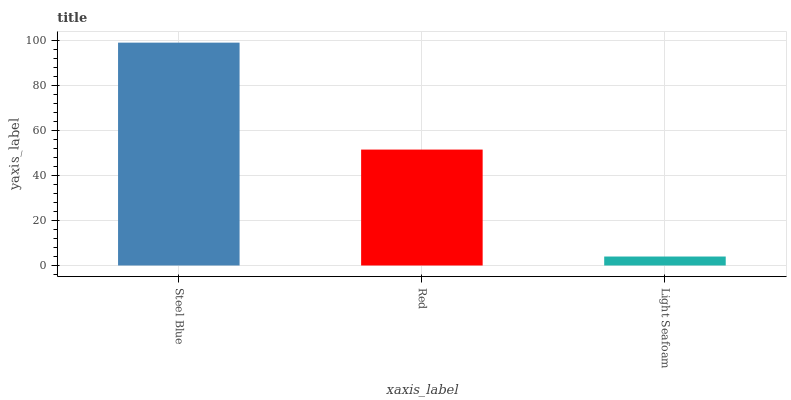Is Red the minimum?
Answer yes or no. No. Is Red the maximum?
Answer yes or no. No. Is Steel Blue greater than Red?
Answer yes or no. Yes. Is Red less than Steel Blue?
Answer yes or no. Yes. Is Red greater than Steel Blue?
Answer yes or no. No. Is Steel Blue less than Red?
Answer yes or no. No. Is Red the high median?
Answer yes or no. Yes. Is Red the low median?
Answer yes or no. Yes. Is Light Seafoam the high median?
Answer yes or no. No. Is Light Seafoam the low median?
Answer yes or no. No. 